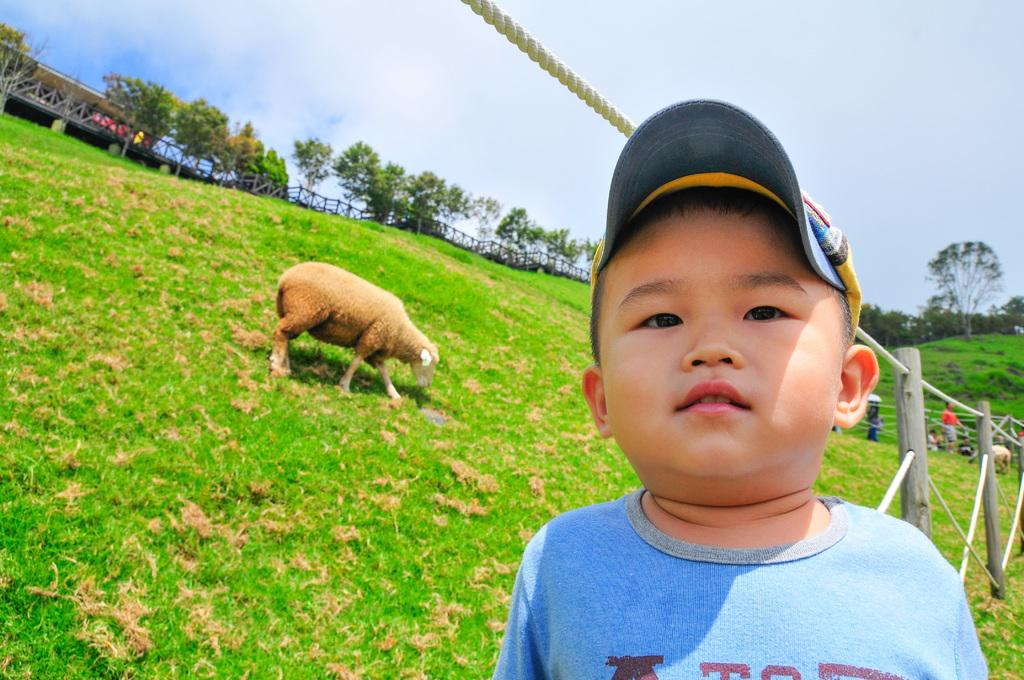What animal can be seen grazing on the left side of the image? There is a sheep grazing on the left side of the image. What is the boy on the right side of the image doing? The boy is looking at his side. What type of clothing is the boy wearing on his head? The boy is wearing a cap. What type of clothing is the boy wearing on his upper body? The boy is wearing a t-shirt. What type of vegetation can be seen in the image? There are trees in the image. What is visible at the top of the image? The sky is visible at the top of the image. What type of jam is the boy spreading on the pipe in the image? There is no jam or pipe present in the image. How does the ball bounce off the sheep's wool in the image? There is no ball present in the image, so it cannot bounce off the sheep's wool. 